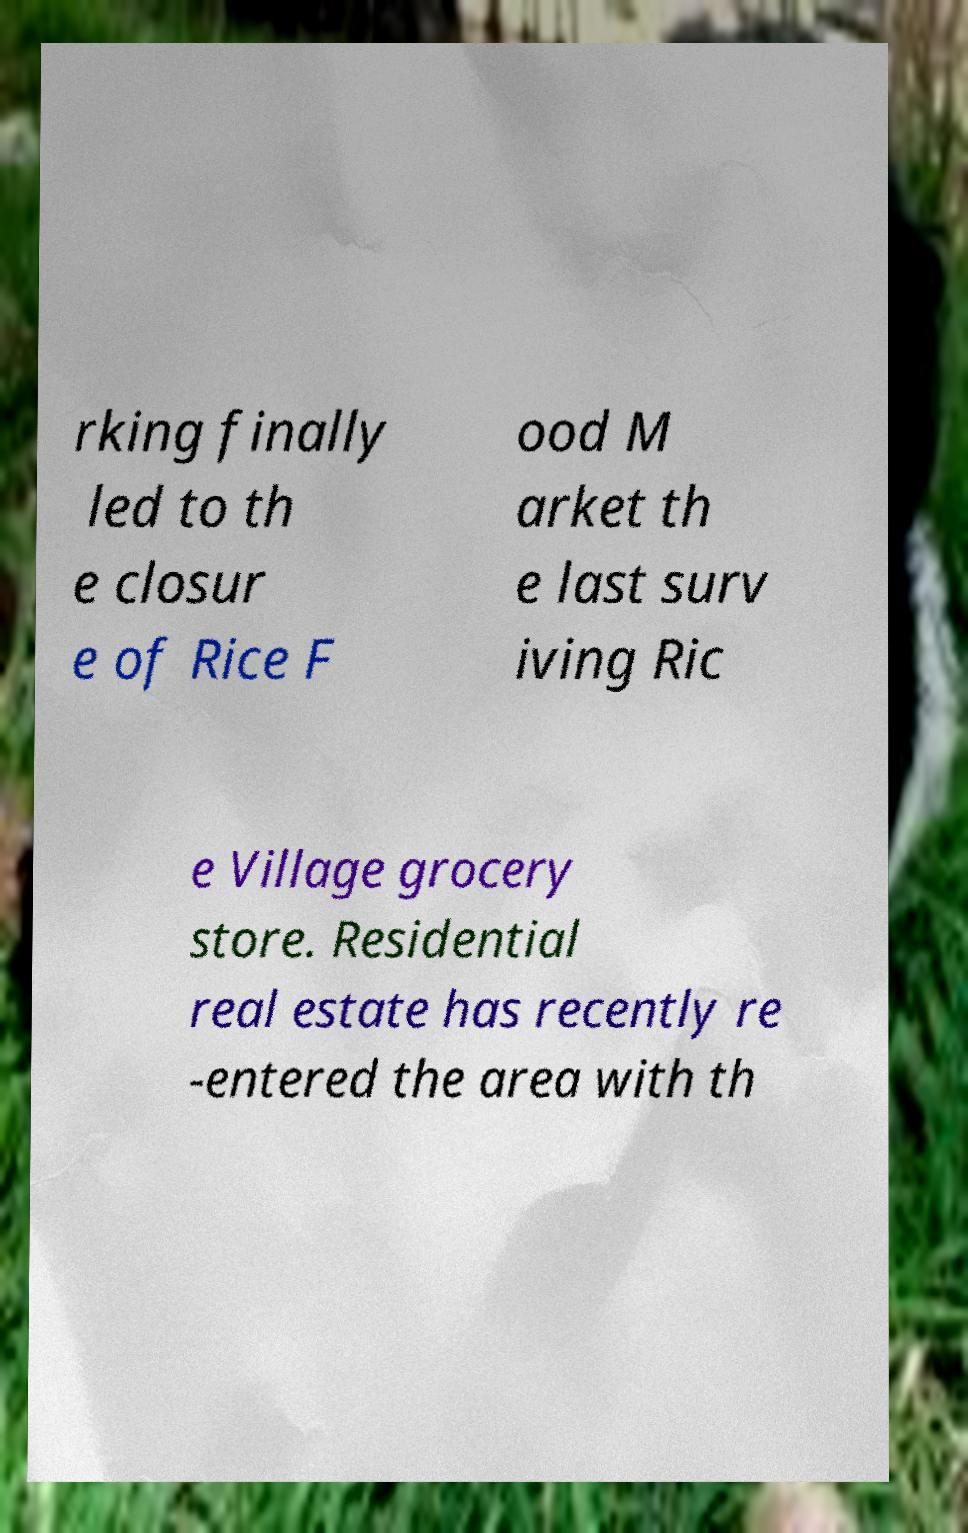There's text embedded in this image that I need extracted. Can you transcribe it verbatim? rking finally led to th e closur e of Rice F ood M arket th e last surv iving Ric e Village grocery store. Residential real estate has recently re -entered the area with th 